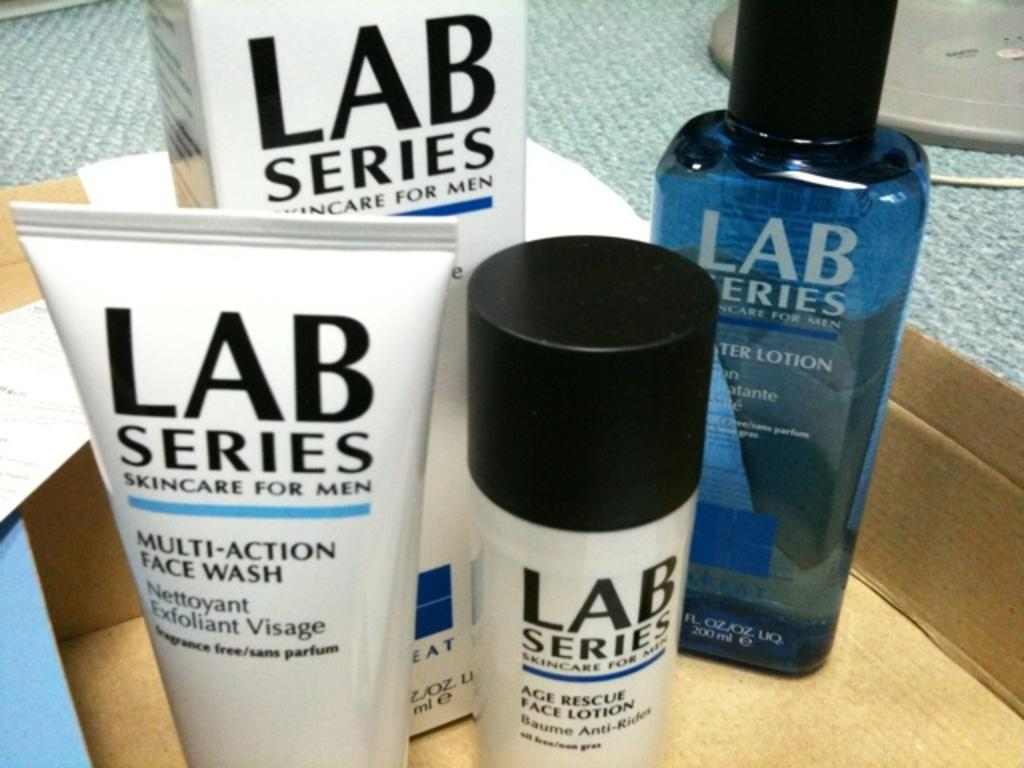<image>
Offer a succinct explanation of the picture presented. Lab series skincare for men on a counter 